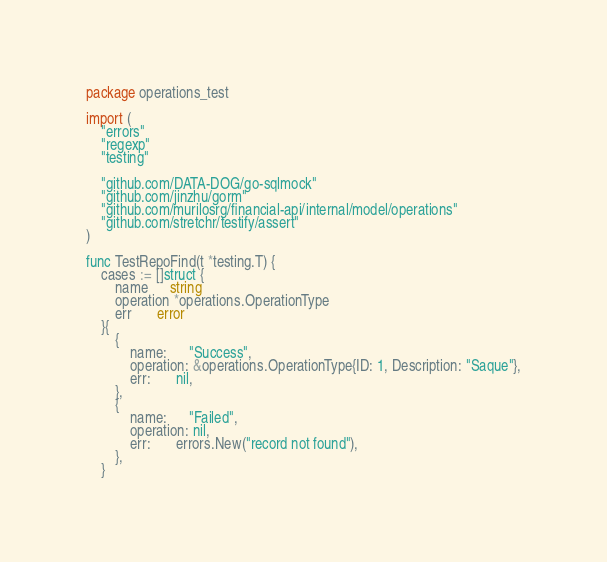Convert code to text. <code><loc_0><loc_0><loc_500><loc_500><_Go_>package operations_test

import (
	"errors"
	"regexp"
	"testing"

	"github.com/DATA-DOG/go-sqlmock"
	"github.com/jinzhu/gorm"
	"github.com/murilosrg/financial-api/internal/model/operations"
	"github.com/stretchr/testify/assert"
)

func TestRepoFind(t *testing.T) {
	cases := []struct {
		name      string
		operation *operations.OperationType
		err       error
	}{
		{
			name:      "Success",
			operation: &operations.OperationType{ID: 1, Description: "Saque"},
			err:       nil,
		},
		{
			name:      "Failed",
			operation: nil,
			err:       errors.New("record not found"),
		},
	}
</code> 